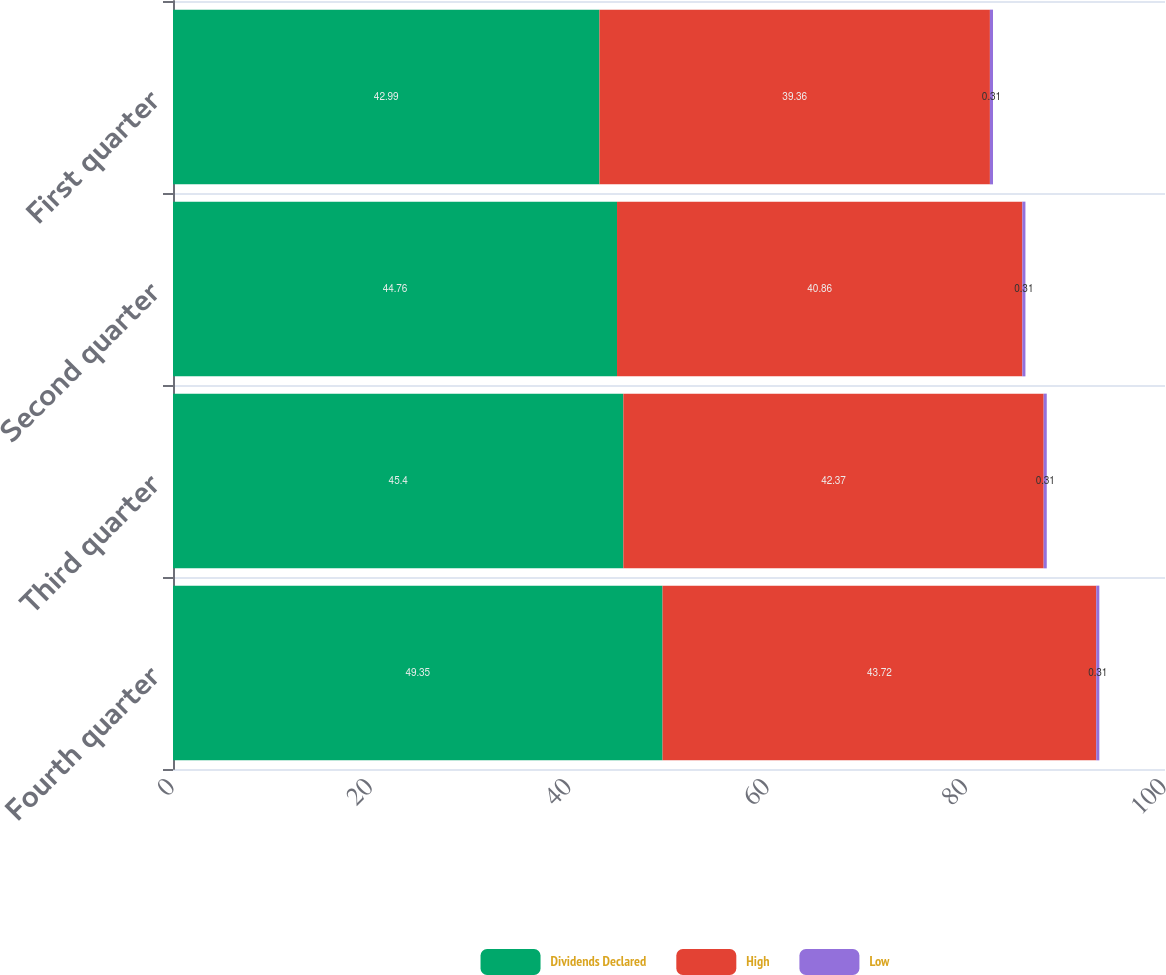Convert chart to OTSL. <chart><loc_0><loc_0><loc_500><loc_500><stacked_bar_chart><ecel><fcel>Fourth quarter<fcel>Third quarter<fcel>Second quarter<fcel>First quarter<nl><fcel>Dividends Declared<fcel>49.35<fcel>45.4<fcel>44.76<fcel>42.99<nl><fcel>High<fcel>43.72<fcel>42.37<fcel>40.86<fcel>39.36<nl><fcel>Low<fcel>0.31<fcel>0.31<fcel>0.31<fcel>0.31<nl></chart> 